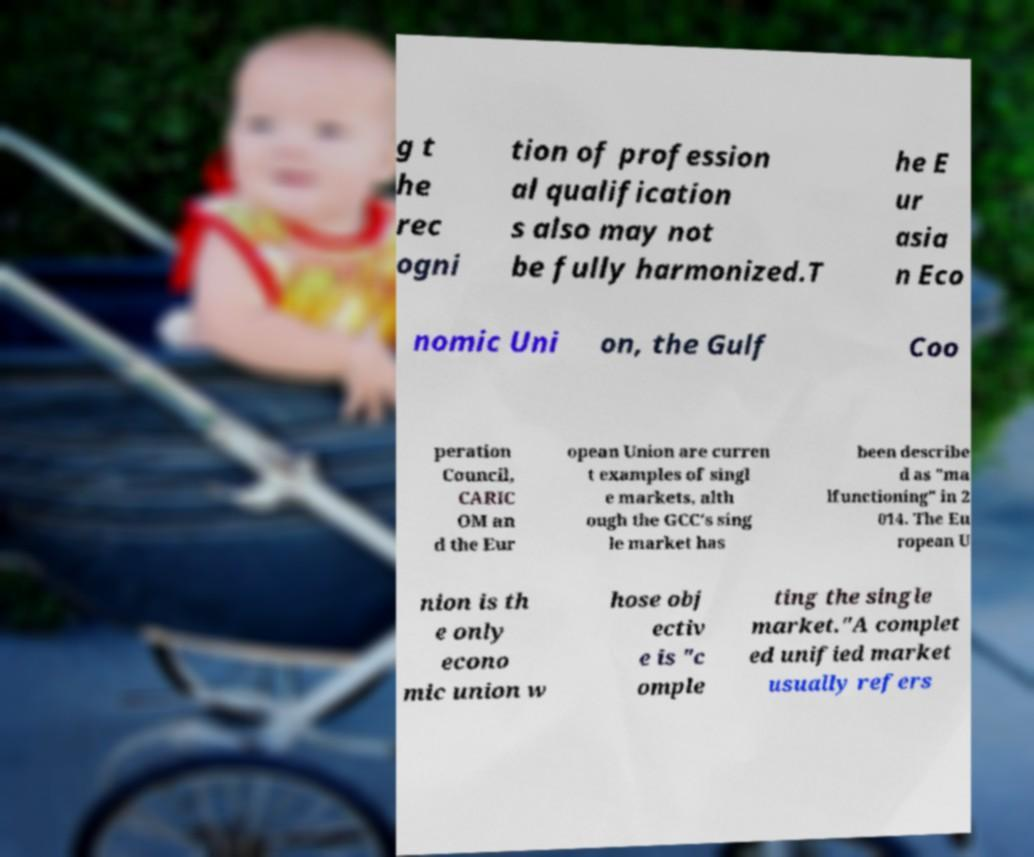Please identify and transcribe the text found in this image. g t he rec ogni tion of profession al qualification s also may not be fully harmonized.T he E ur asia n Eco nomic Uni on, the Gulf Coo peration Council, CARIC OM an d the Eur opean Union are curren t examples of singl e markets, alth ough the GCC's sing le market has been describe d as "ma lfunctioning" in 2 014. The Eu ropean U nion is th e only econo mic union w hose obj ectiv e is "c omple ting the single market."A complet ed unified market usually refers 